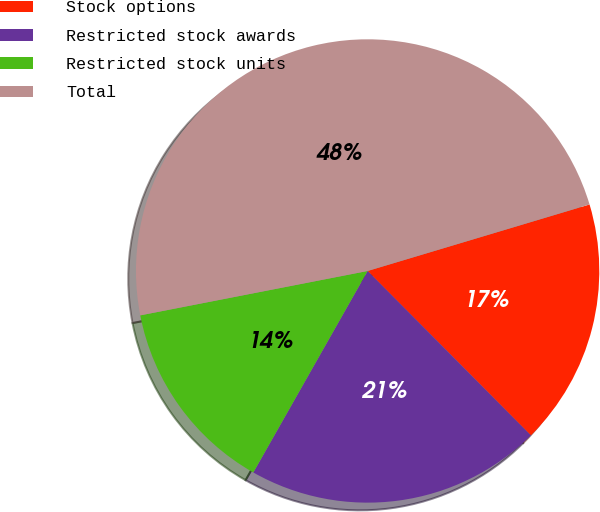Convert chart to OTSL. <chart><loc_0><loc_0><loc_500><loc_500><pie_chart><fcel>Stock options<fcel>Restricted stock awards<fcel>Restricted stock units<fcel>Total<nl><fcel>17.19%<fcel>20.66%<fcel>13.72%<fcel>48.44%<nl></chart> 